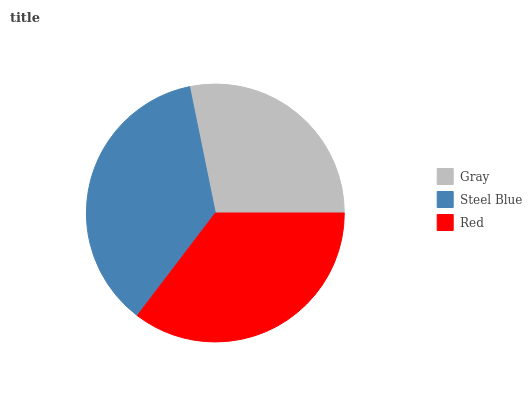Is Gray the minimum?
Answer yes or no. Yes. Is Steel Blue the maximum?
Answer yes or no. Yes. Is Red the minimum?
Answer yes or no. No. Is Red the maximum?
Answer yes or no. No. Is Steel Blue greater than Red?
Answer yes or no. Yes. Is Red less than Steel Blue?
Answer yes or no. Yes. Is Red greater than Steel Blue?
Answer yes or no. No. Is Steel Blue less than Red?
Answer yes or no. No. Is Red the high median?
Answer yes or no. Yes. Is Red the low median?
Answer yes or no. Yes. Is Gray the high median?
Answer yes or no. No. Is Steel Blue the low median?
Answer yes or no. No. 